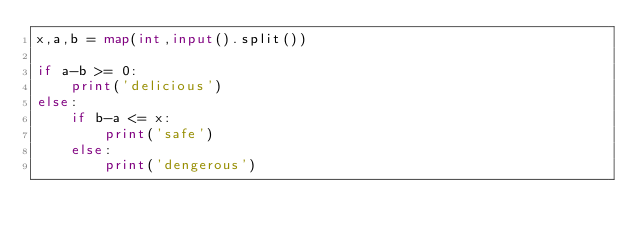<code> <loc_0><loc_0><loc_500><loc_500><_Python_>x,a,b = map(int,input().split())

if a-b >= 0:
    print('delicious')
else:
    if b-a <= x:
        print('safe')
    else:
        print('dengerous')</code> 